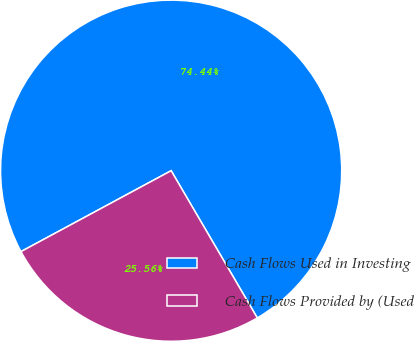<chart> <loc_0><loc_0><loc_500><loc_500><pie_chart><fcel>Cash Flows Used in Investing<fcel>Cash Flows Provided by (Used<nl><fcel>74.44%<fcel>25.56%<nl></chart> 